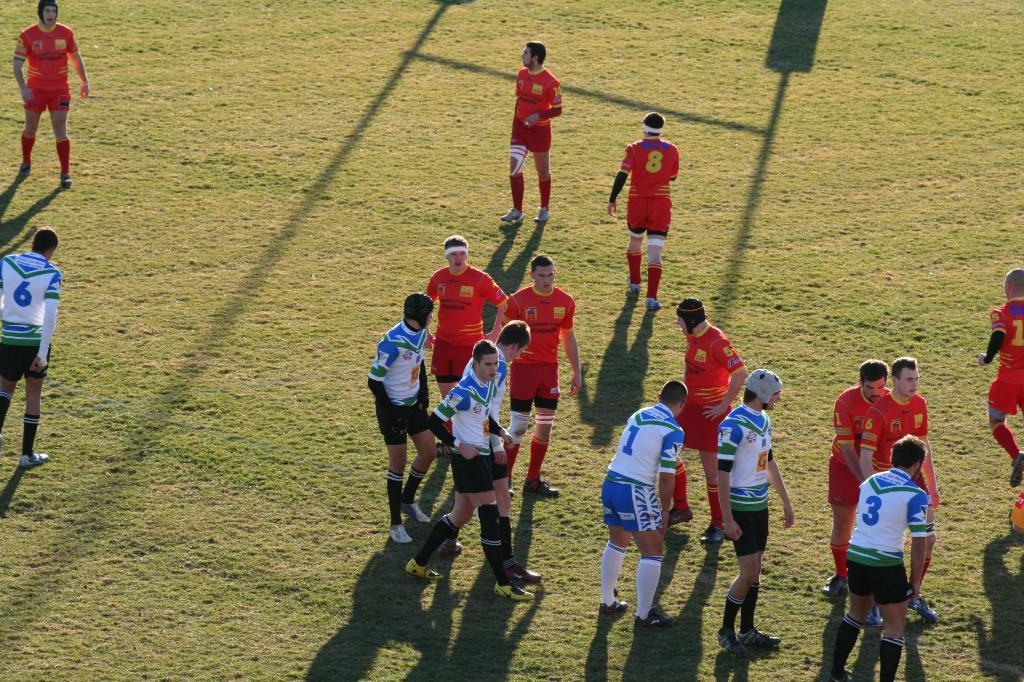<image>
Render a clear and concise summary of the photo. Players on the white and blue team include those wearing numbers 1 and 3. 